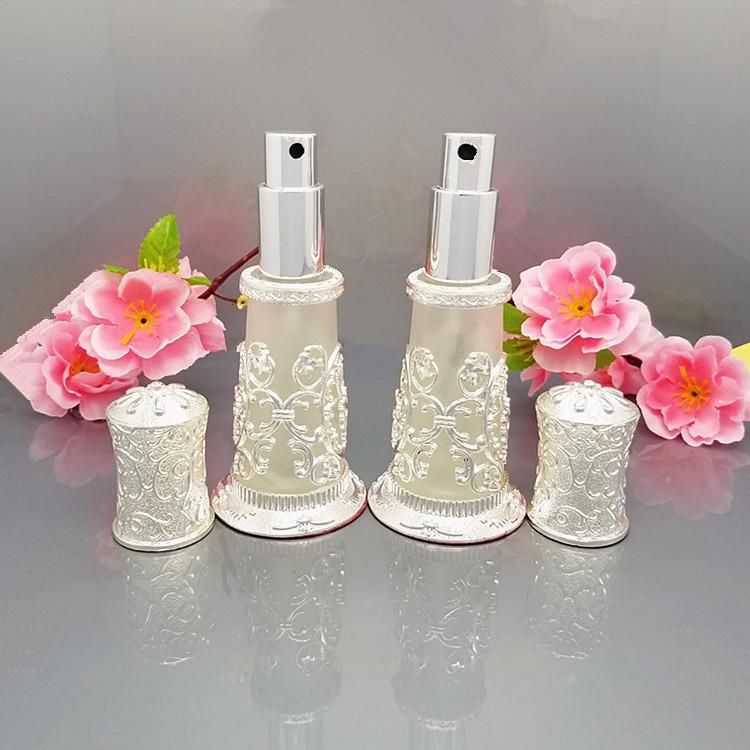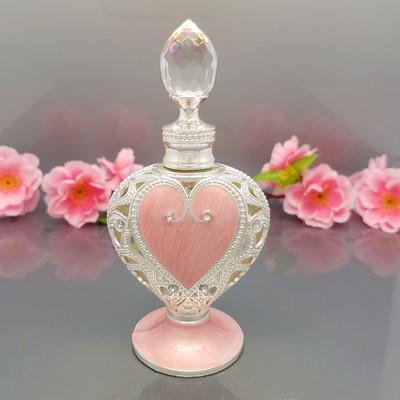The first image is the image on the left, the second image is the image on the right. Given the left and right images, does the statement "One of the images includes a string of pearls on the table." hold true? Answer yes or no. No. 